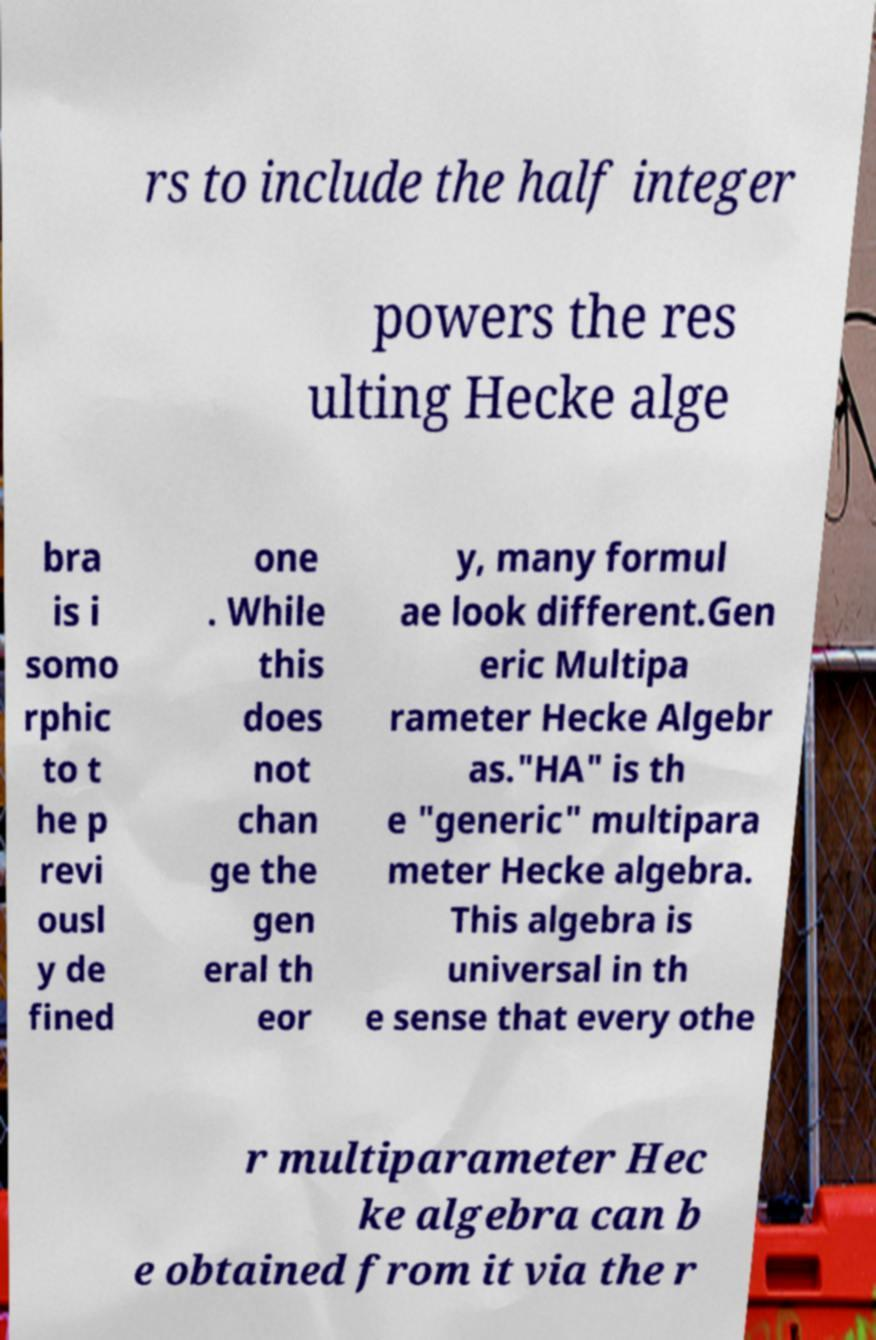What messages or text are displayed in this image? I need them in a readable, typed format. rs to include the half integer powers the res ulting Hecke alge bra is i somo rphic to t he p revi ousl y de fined one . While this does not chan ge the gen eral th eor y, many formul ae look different.Gen eric Multipa rameter Hecke Algebr as."HA" is th e "generic" multipara meter Hecke algebra. This algebra is universal in th e sense that every othe r multiparameter Hec ke algebra can b e obtained from it via the r 